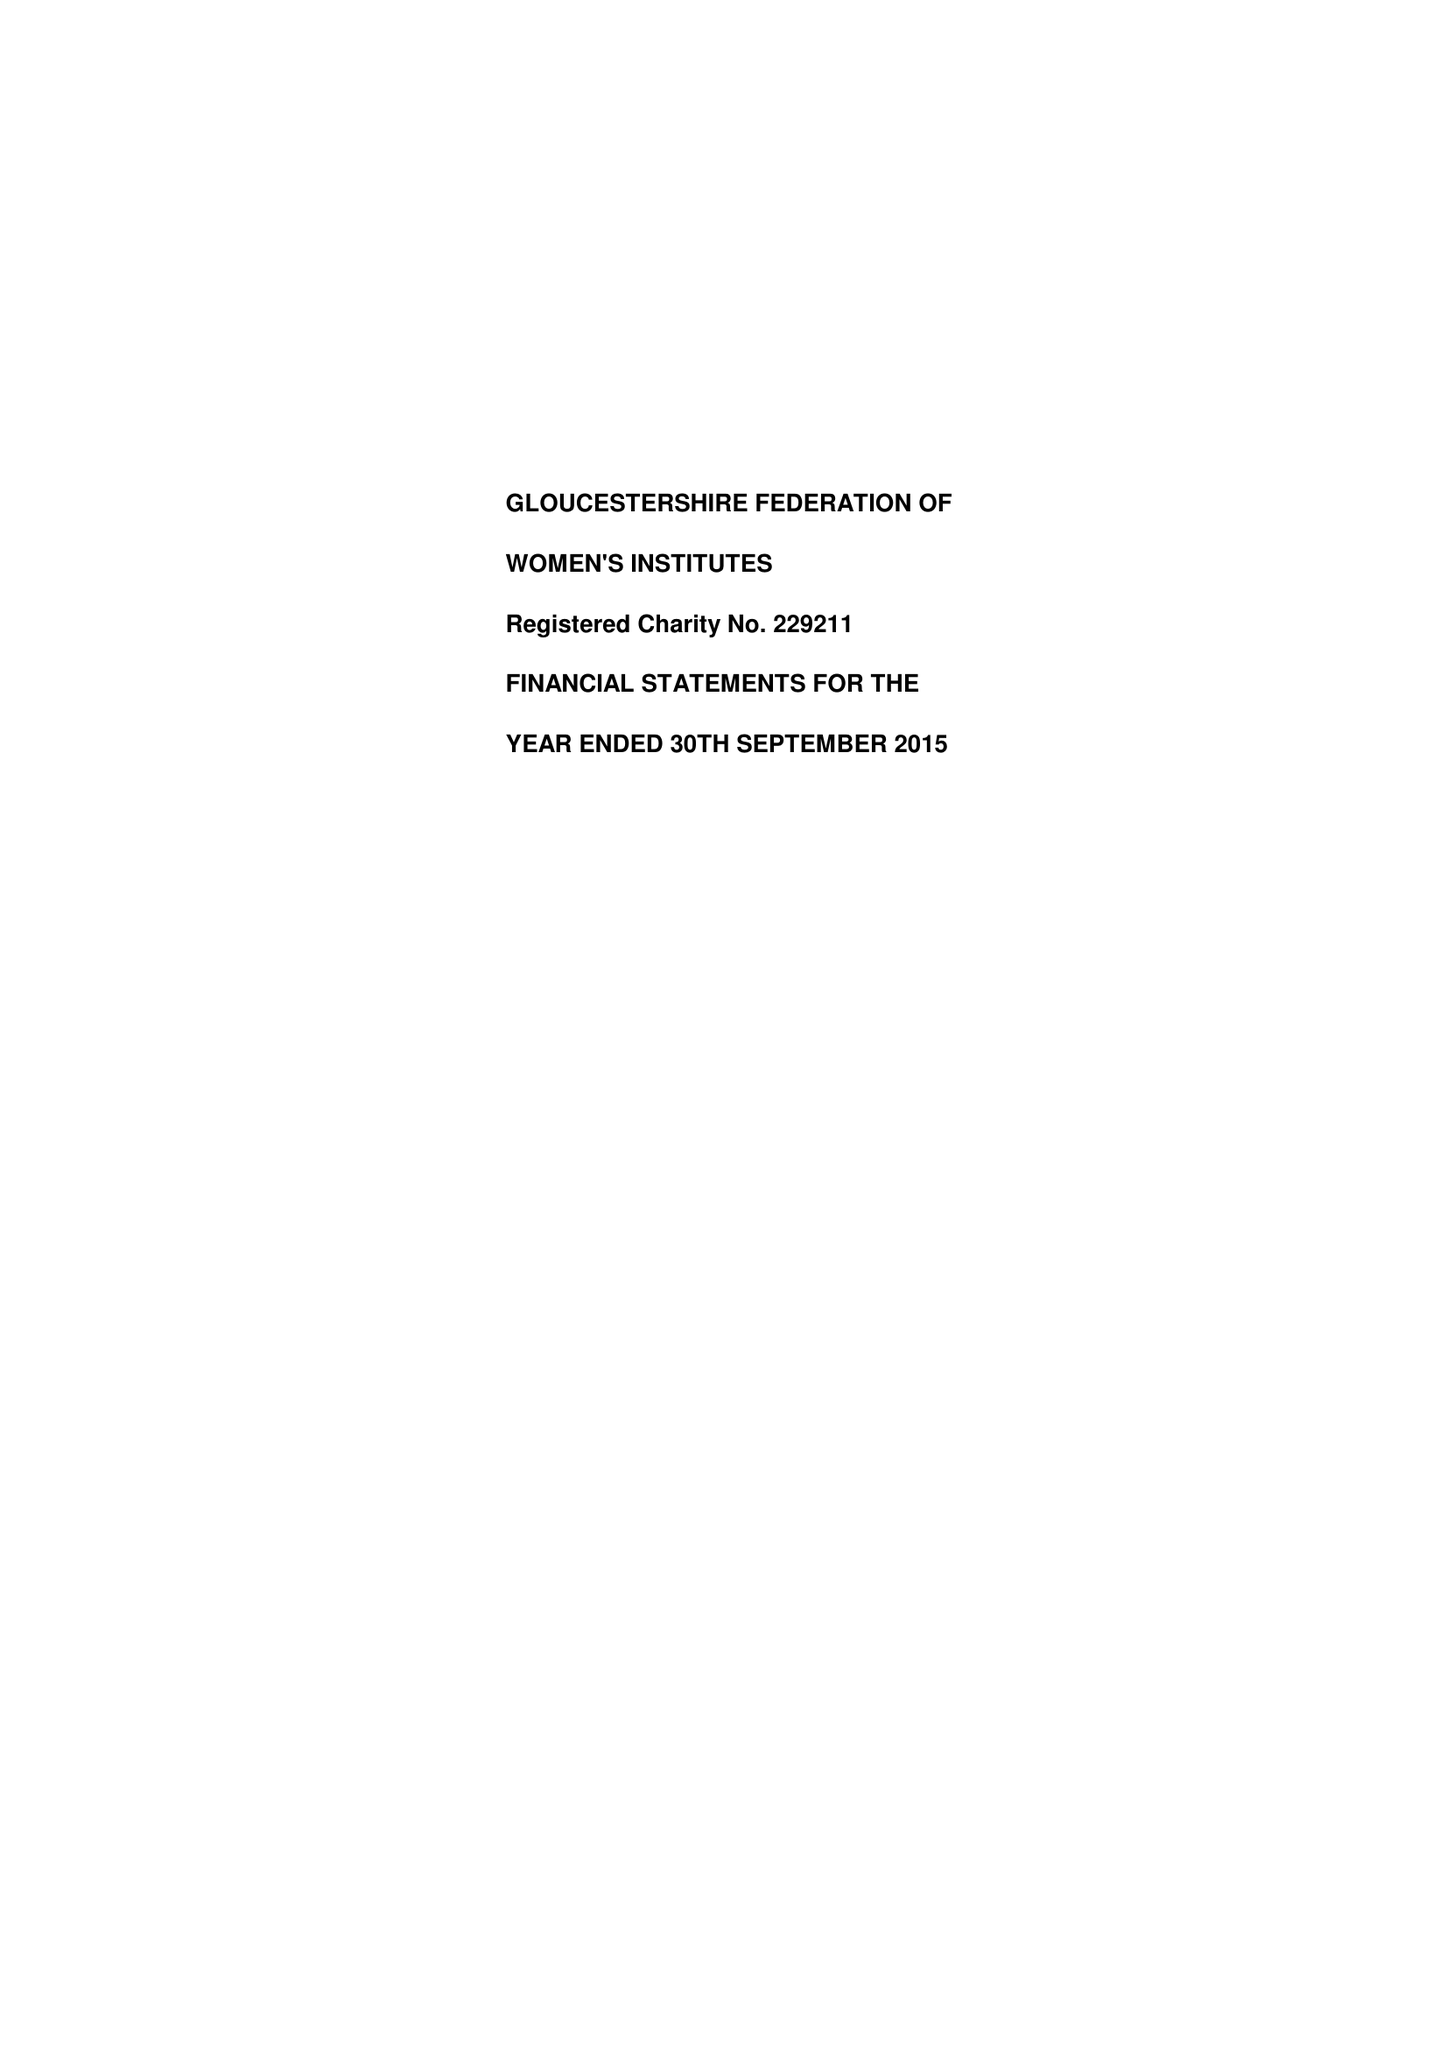What is the value for the report_date?
Answer the question using a single word or phrase. 2015-09-30 